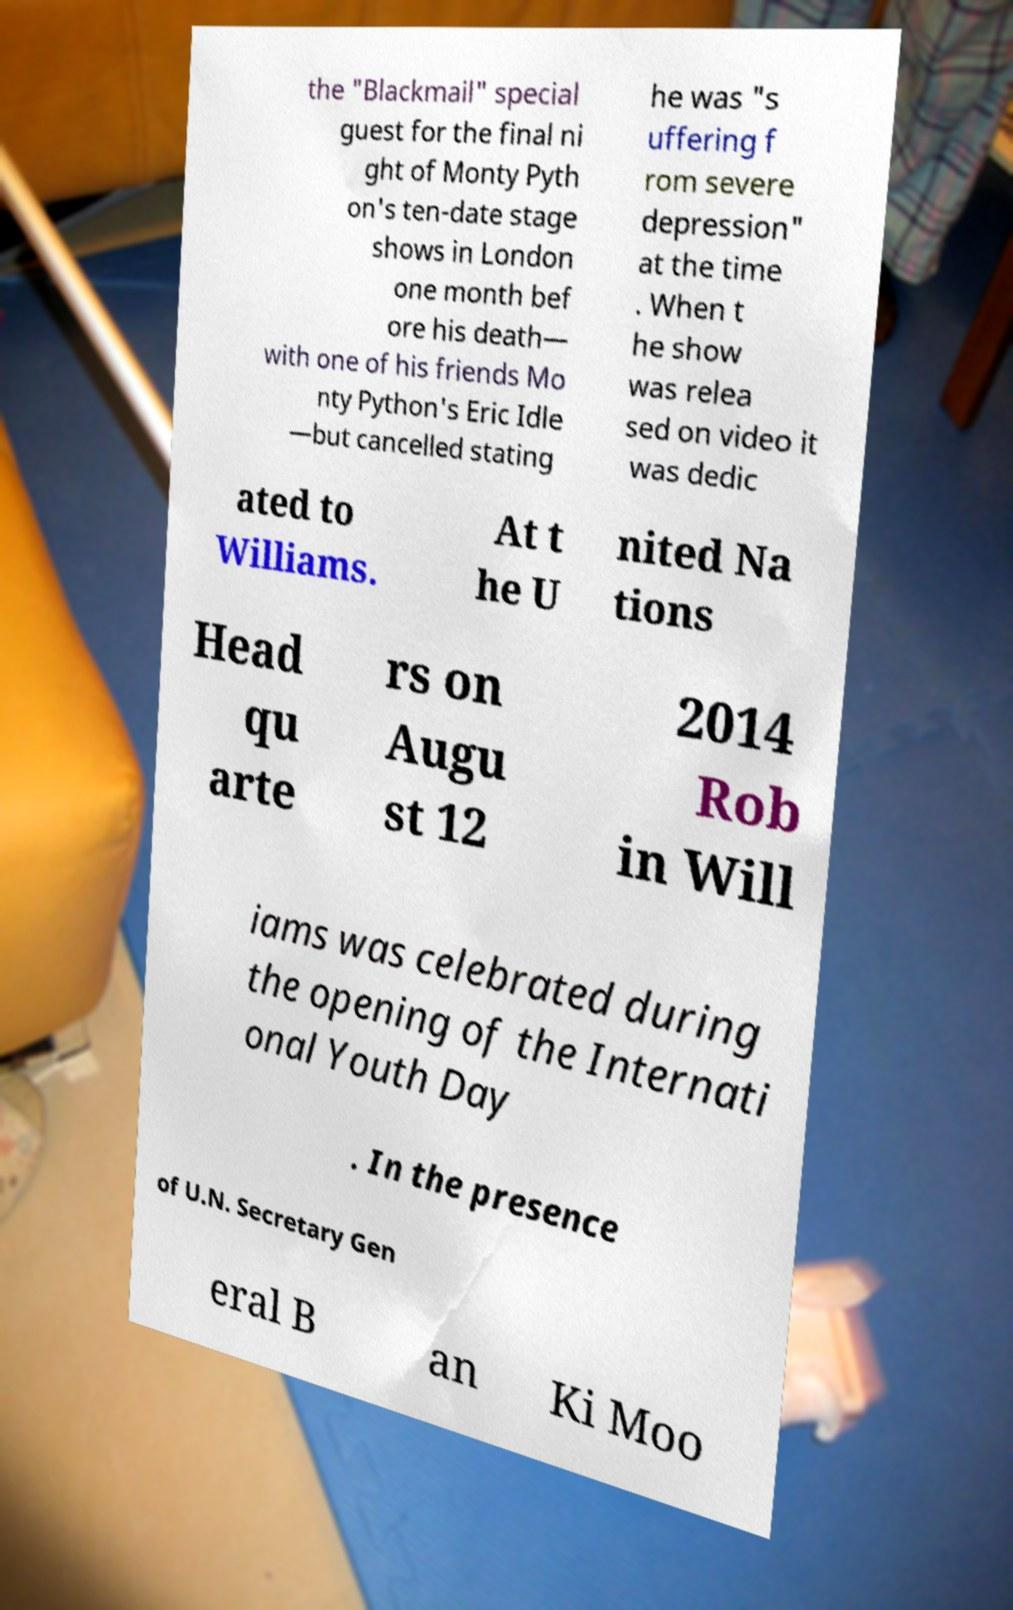For documentation purposes, I need the text within this image transcribed. Could you provide that? the "Blackmail" special guest for the final ni ght of Monty Pyth on's ten-date stage shows in London one month bef ore his death— with one of his friends Mo nty Python's Eric Idle —but cancelled stating he was "s uffering f rom severe depression" at the time . When t he show was relea sed on video it was dedic ated to Williams. At t he U nited Na tions Head qu arte rs on Augu st 12 2014 Rob in Will iams was celebrated during the opening of the Internati onal Youth Day . In the presence of U.N. Secretary Gen eral B an Ki Moo 